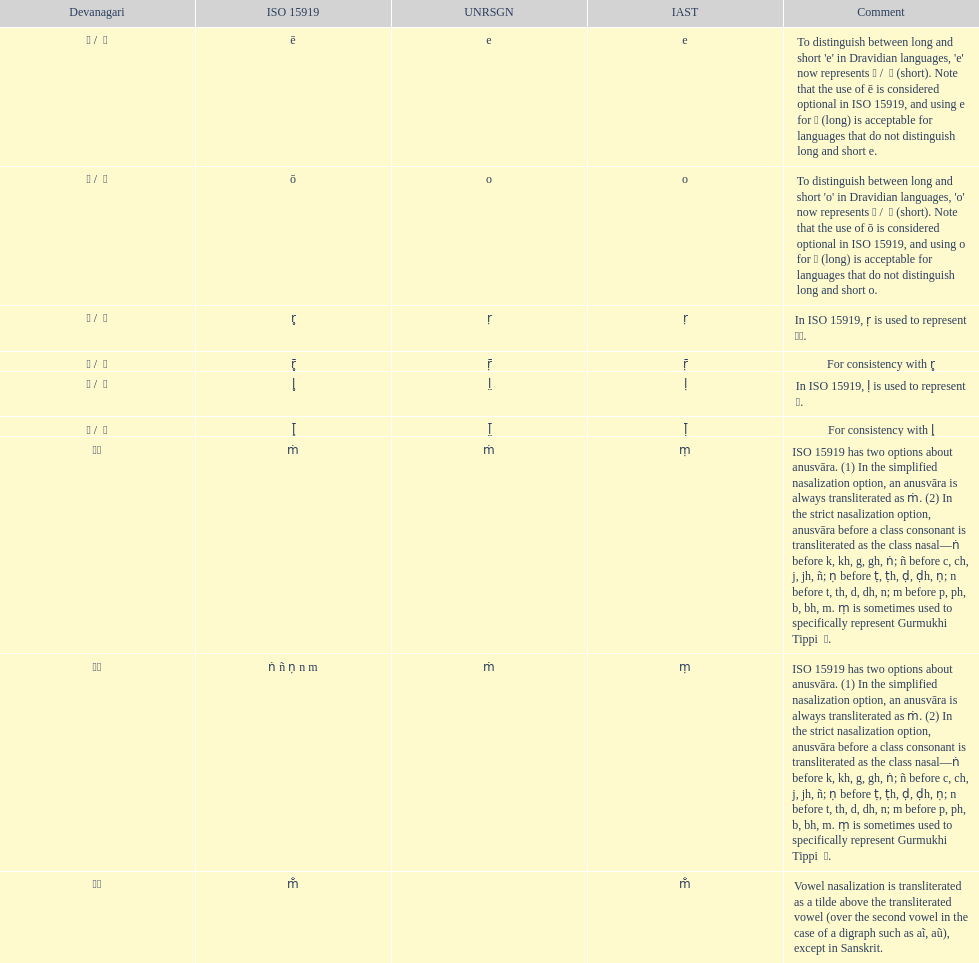Give me the full table as a dictionary. {'header': ['Devanagari', 'ISO 15919', 'UNRSGN', 'IAST', 'Comment'], 'rows': [['ए / \xa0े', 'ē', 'e', 'e', "To distinguish between long and short 'e' in Dravidian languages, 'e' now represents ऎ / \xa0ॆ (short). Note that the use of ē is considered optional in ISO 15919, and using e for ए (long) is acceptable for languages that do not distinguish long and short e."], ['ओ / \xa0ो', 'ō', 'o', 'o', "To distinguish between long and short 'o' in Dravidian languages, 'o' now represents ऒ / \xa0ॊ (short). Note that the use of ō is considered optional in ISO 15919, and using o for ओ (long) is acceptable for languages that do not distinguish long and short o."], ['ऋ / \xa0ृ', 'r̥', 'ṛ', 'ṛ', 'In ISO 15919, ṛ is used to represent ड़.'], ['ॠ / \xa0ॄ', 'r̥̄', 'ṝ', 'ṝ', 'For consistency with r̥'], ['ऌ / \xa0ॢ', 'l̥', 'l̤', 'ḷ', 'In ISO 15919, ḷ is used to represent ळ.'], ['ॡ / \xa0ॣ', 'l̥̄', 'l̤̄', 'ḹ', 'For consistency with l̥'], ['◌ं', 'ṁ', 'ṁ', 'ṃ', 'ISO 15919 has two options about anusvāra. (1) In the simplified nasalization option, an anusvāra is always transliterated as ṁ. (2) In the strict nasalization option, anusvāra before a class consonant is transliterated as the class nasal—ṅ before k, kh, g, gh, ṅ; ñ before c, ch, j, jh, ñ; ṇ before ṭ, ṭh, ḍ, ḍh, ṇ; n before t, th, d, dh, n; m before p, ph, b, bh, m. ṃ is sometimes used to specifically represent Gurmukhi Tippi \xa0ੰ.'], ['◌ं', 'ṅ ñ ṇ n m', 'ṁ', 'ṃ', 'ISO 15919 has two options about anusvāra. (1) In the simplified nasalization option, an anusvāra is always transliterated as ṁ. (2) In the strict nasalization option, anusvāra before a class consonant is transliterated as the class nasal—ṅ before k, kh, g, gh, ṅ; ñ before c, ch, j, jh, ñ; ṇ before ṭ, ṭh, ḍ, ḍh, ṇ; n before t, th, d, dh, n; m before p, ph, b, bh, m. ṃ is sometimes used to specifically represent Gurmukhi Tippi \xa0ੰ.'], ['◌ँ', 'm̐', '', 'm̐', 'Vowel nasalization is transliterated as a tilde above the transliterated vowel (over the second vowel in the case of a digraph such as aĩ, aũ), except in Sanskrit.']]} What is the overall count of translations? 8. 